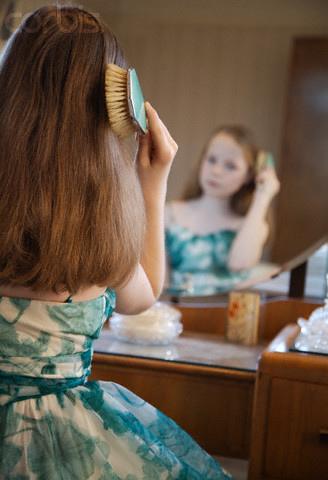What is the girl looking at?
Concise answer only. Herself. Is the girl brushing her hair?
Write a very short answer. Yes. What color is the girls dress?
Concise answer only. Green. 